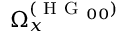Convert formula to latex. <formula><loc_0><loc_0><loc_500><loc_500>\Omega _ { x } ^ { ( H G _ { 0 0 } ) }</formula> 